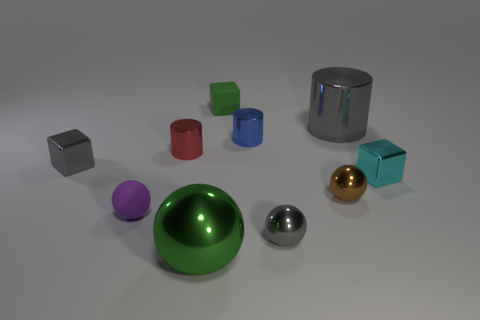Is the number of green matte blocks that are in front of the tiny purple thing less than the number of cyan metal spheres?
Make the answer very short. No. What shape is the rubber object that is behind the blue cylinder?
Provide a succinct answer. Cube. There is a gray block; does it have the same size as the metallic cylinder that is right of the tiny gray metallic sphere?
Offer a terse response. No. Are there any small objects that have the same material as the gray ball?
Make the answer very short. Yes. What number of blocks are tiny brown metallic things or cyan objects?
Offer a terse response. 1. There is a large metallic object in front of the tiny cyan shiny thing; is there a gray shiny block in front of it?
Make the answer very short. No. Is the number of cylinders less than the number of balls?
Make the answer very short. Yes. What number of tiny cyan things are the same shape as the brown object?
Provide a short and direct response. 0. What number of brown things are either large metal cylinders or large metallic objects?
Give a very brief answer. 0. How big is the purple object that is in front of the green object that is behind the tiny cyan block?
Offer a terse response. Small. 